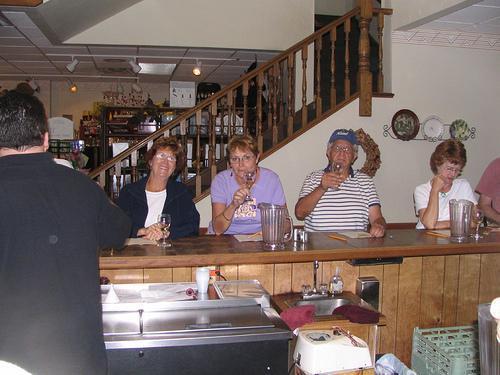How many people are in the photo?
Give a very brief answer. 6. How many people are wearing hats?
Give a very brief answer. 1. How many people can be seen?
Give a very brief answer. 5. 